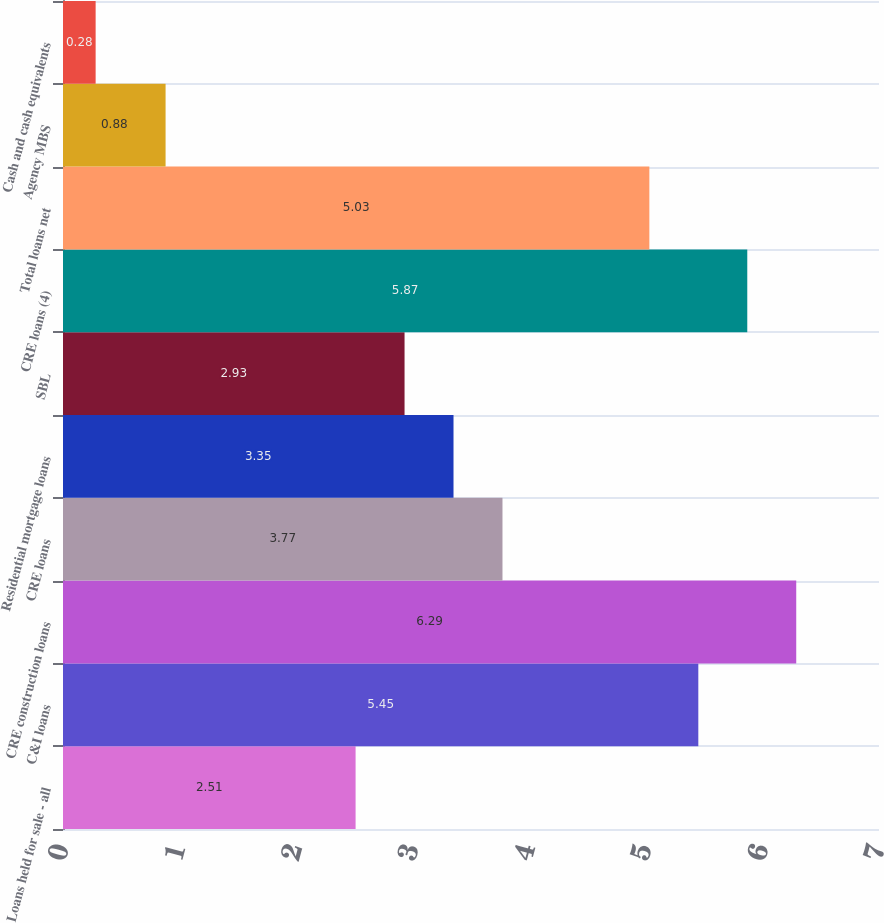Convert chart to OTSL. <chart><loc_0><loc_0><loc_500><loc_500><bar_chart><fcel>Loans held for sale - all<fcel>C&I loans<fcel>CRE construction loans<fcel>CRE loans<fcel>Residential mortgage loans<fcel>SBL<fcel>CRE loans (4)<fcel>Total loans net<fcel>Agency MBS<fcel>Cash and cash equivalents<nl><fcel>2.51<fcel>5.45<fcel>6.29<fcel>3.77<fcel>3.35<fcel>2.93<fcel>5.87<fcel>5.03<fcel>0.88<fcel>0.28<nl></chart> 